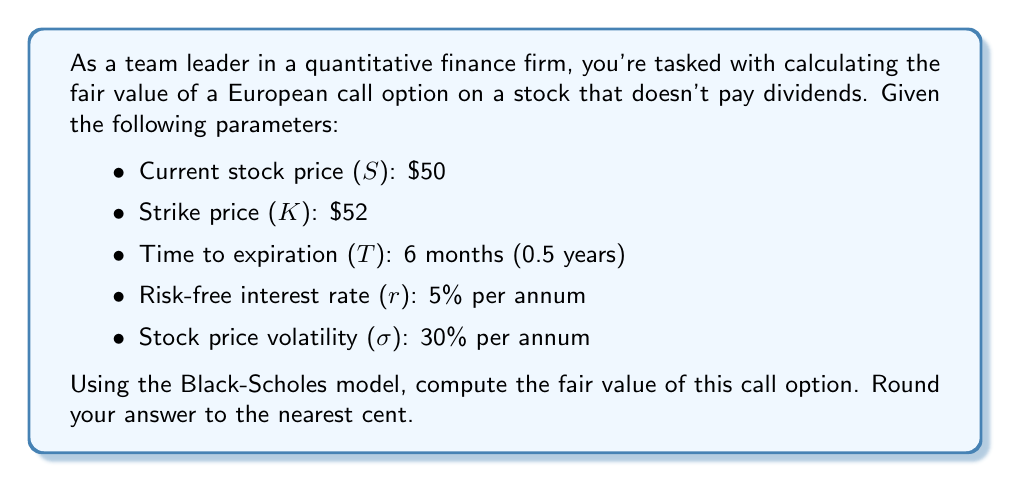Show me your answer to this math problem. To calculate the fair value of a European call option using the Black-Scholes model, we'll follow these steps:

1. Calculate d1 and d2:

$$d_1 = \frac{\ln(S/K) + (r + \sigma^2/2)T}{\sigma\sqrt{T}}$$
$$d_2 = d_1 - \sigma\sqrt{T}$$

2. Calculate N(d1) and N(d2), which are the cumulative standard normal distribution functions.

3. Apply the Black-Scholes formula for a call option:

$$C = SN(d_1) - Ke^{-rT}N(d_2)$$

Let's proceed with the calculations:

Step 1: Calculate d1 and d2

$$d_1 = \frac{\ln(50/52) + (0.05 + 0.3^2/2) * 0.5}{0.3\sqrt{0.5}} = 0.0891$$

$$d_2 = 0.0891 - 0.3\sqrt{0.5} = -0.1231$$

Step 2: Calculate N(d1) and N(d2)

Using a standard normal distribution table or calculator:

N(d1) = N(0.0891) ≈ 0.5355
N(d2) = N(-0.1231) ≈ 0.4510

Step 3: Apply the Black-Scholes formula

$$C = 50 * 0.5355 - 52 * e^{-0.05 * 0.5} * 0.4510$$

$$C = 26.7750 - 52 * 0.9753 * 0.4510$$

$$C = 26.7750 - 22.8741 = 3.9009$$

Rounding to the nearest cent, we get $3.90.
Answer: $3.90 